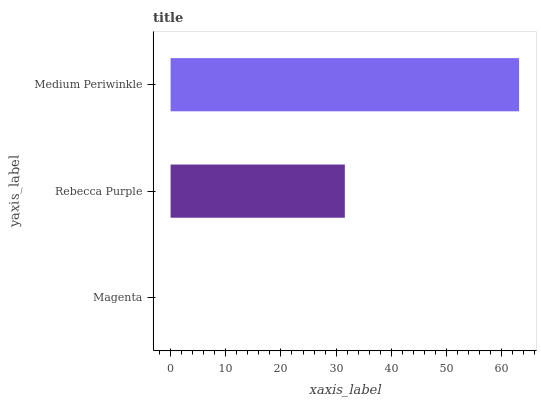Is Magenta the minimum?
Answer yes or no. Yes. Is Medium Periwinkle the maximum?
Answer yes or no. Yes. Is Rebecca Purple the minimum?
Answer yes or no. No. Is Rebecca Purple the maximum?
Answer yes or no. No. Is Rebecca Purple greater than Magenta?
Answer yes or no. Yes. Is Magenta less than Rebecca Purple?
Answer yes or no. Yes. Is Magenta greater than Rebecca Purple?
Answer yes or no. No. Is Rebecca Purple less than Magenta?
Answer yes or no. No. Is Rebecca Purple the high median?
Answer yes or no. Yes. Is Rebecca Purple the low median?
Answer yes or no. Yes. Is Medium Periwinkle the high median?
Answer yes or no. No. Is Medium Periwinkle the low median?
Answer yes or no. No. 